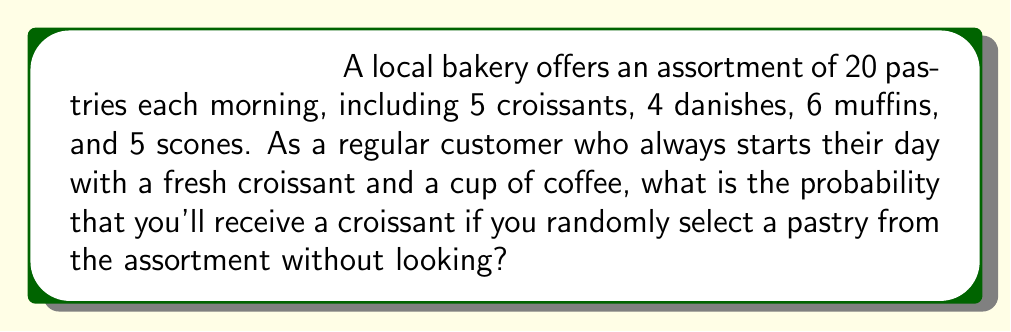Provide a solution to this math problem. To solve this problem, we need to use the basic probability formula:

$$ P(event) = \frac{\text{number of favorable outcomes}}{\text{total number of possible outcomes}} $$

In this case:
1. The favorable outcome is selecting a croissant.
2. The total number of possible outcomes is the total number of pastries in the assortment.

Let's break it down step-by-step:

1. Number of favorable outcomes (croissants): 5
2. Total number of possible outcomes (all pastries): 5 + 4 + 6 + 5 = 20

Now, we can plug these values into our probability formula:

$$ P(\text{croissant}) = \frac{5}{20} $$

To simplify this fraction:

$$ P(\text{croissant}) = \frac{5}{20} = \frac{1}{4} = 0.25 $$

Therefore, the probability of randomly selecting a croissant from the bakery's assortment is $\frac{1}{4}$ or 0.25 or 25%.
Answer: $\frac{1}{4}$ or 0.25 or 25% 